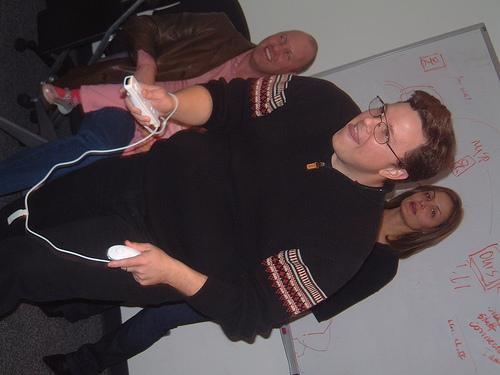How many players are there? Please explain your reasoning. one. There is only one person with the console. 